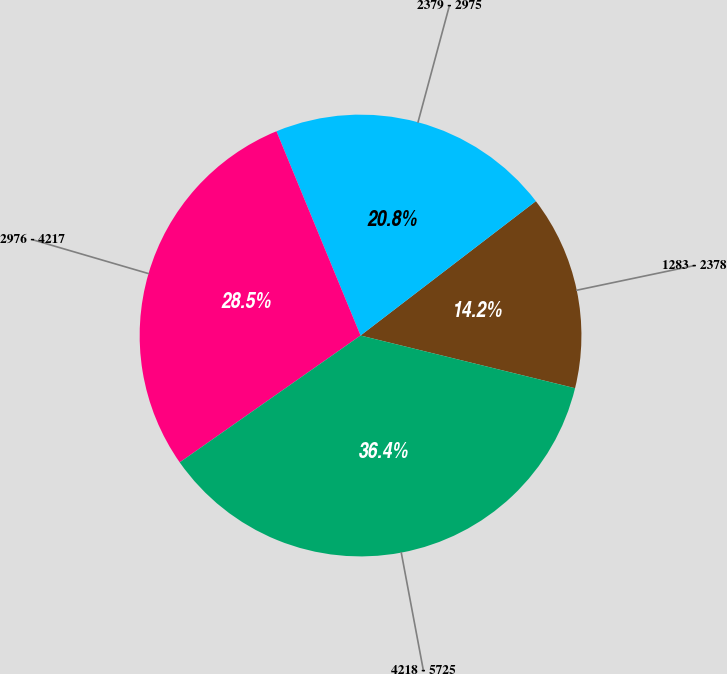Convert chart to OTSL. <chart><loc_0><loc_0><loc_500><loc_500><pie_chart><fcel>1283 - 2378<fcel>2379 - 2975<fcel>2976 - 4217<fcel>4218 - 5725<nl><fcel>14.24%<fcel>20.81%<fcel>28.52%<fcel>36.43%<nl></chart> 